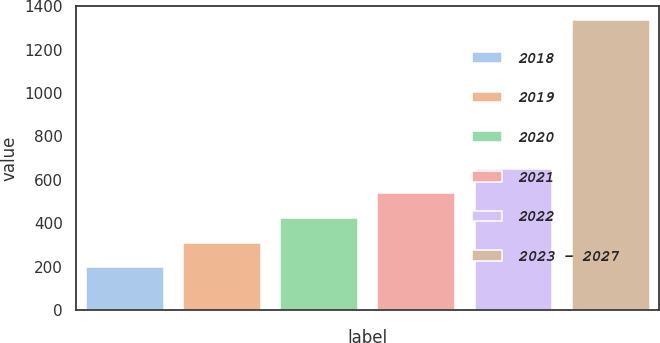<chart> <loc_0><loc_0><loc_500><loc_500><bar_chart><fcel>2018<fcel>2019<fcel>2020<fcel>2021<fcel>2022<fcel>2023 - 2027<nl><fcel>198<fcel>311.6<fcel>425.2<fcel>538.8<fcel>652.4<fcel>1334<nl></chart> 